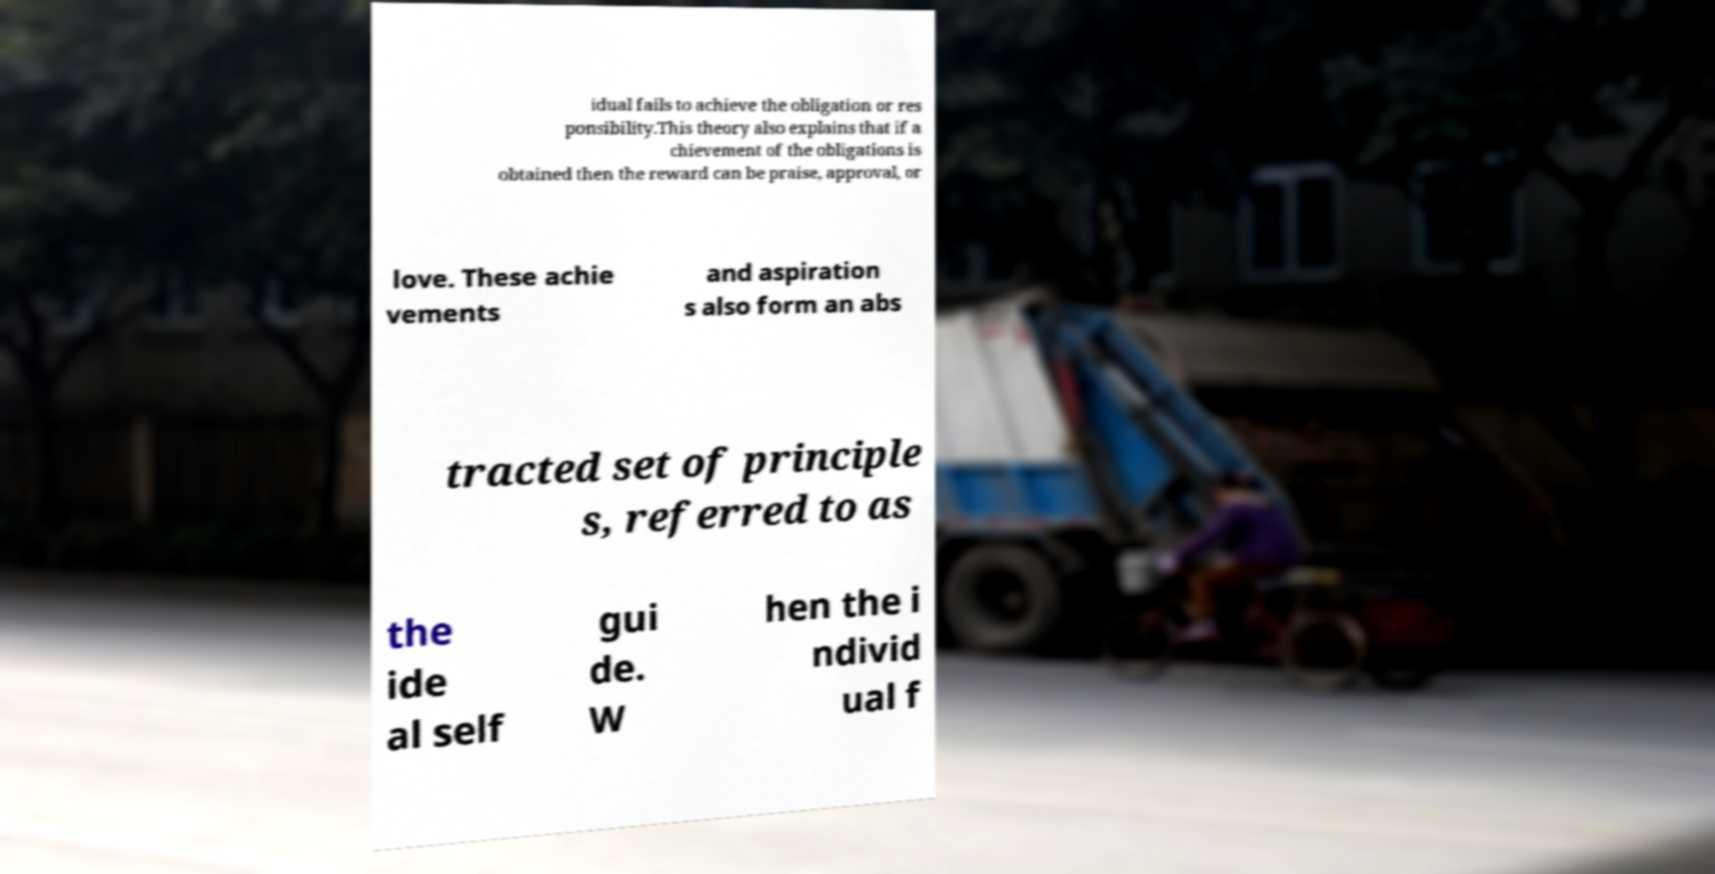Please read and relay the text visible in this image. What does it say? idual fails to achieve the obligation or res ponsibility.This theory also explains that if a chievement of the obligations is obtained then the reward can be praise, approval, or love. These achie vements and aspiration s also form an abs tracted set of principle s, referred to as the ide al self gui de. W hen the i ndivid ual f 